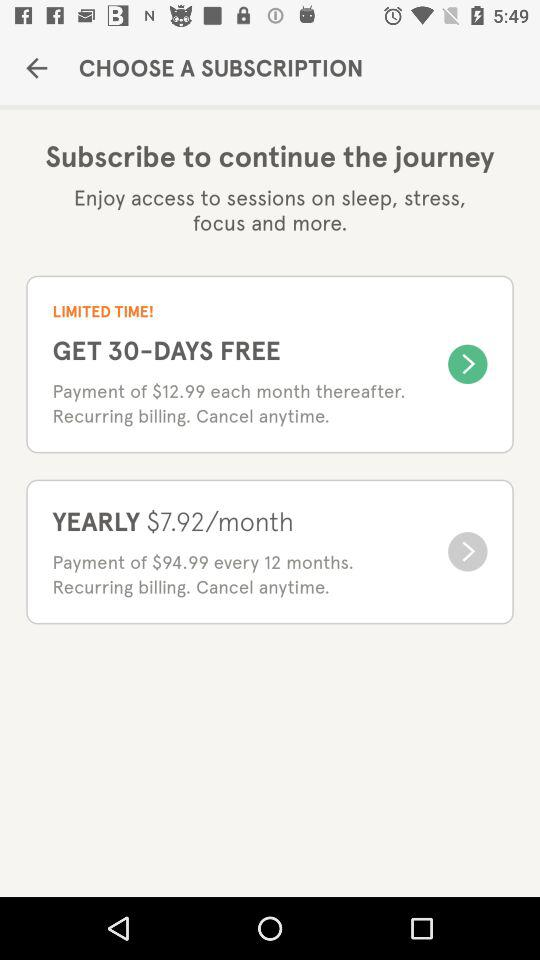For how many days is the free trial available? The free trial is available for 30 days. 